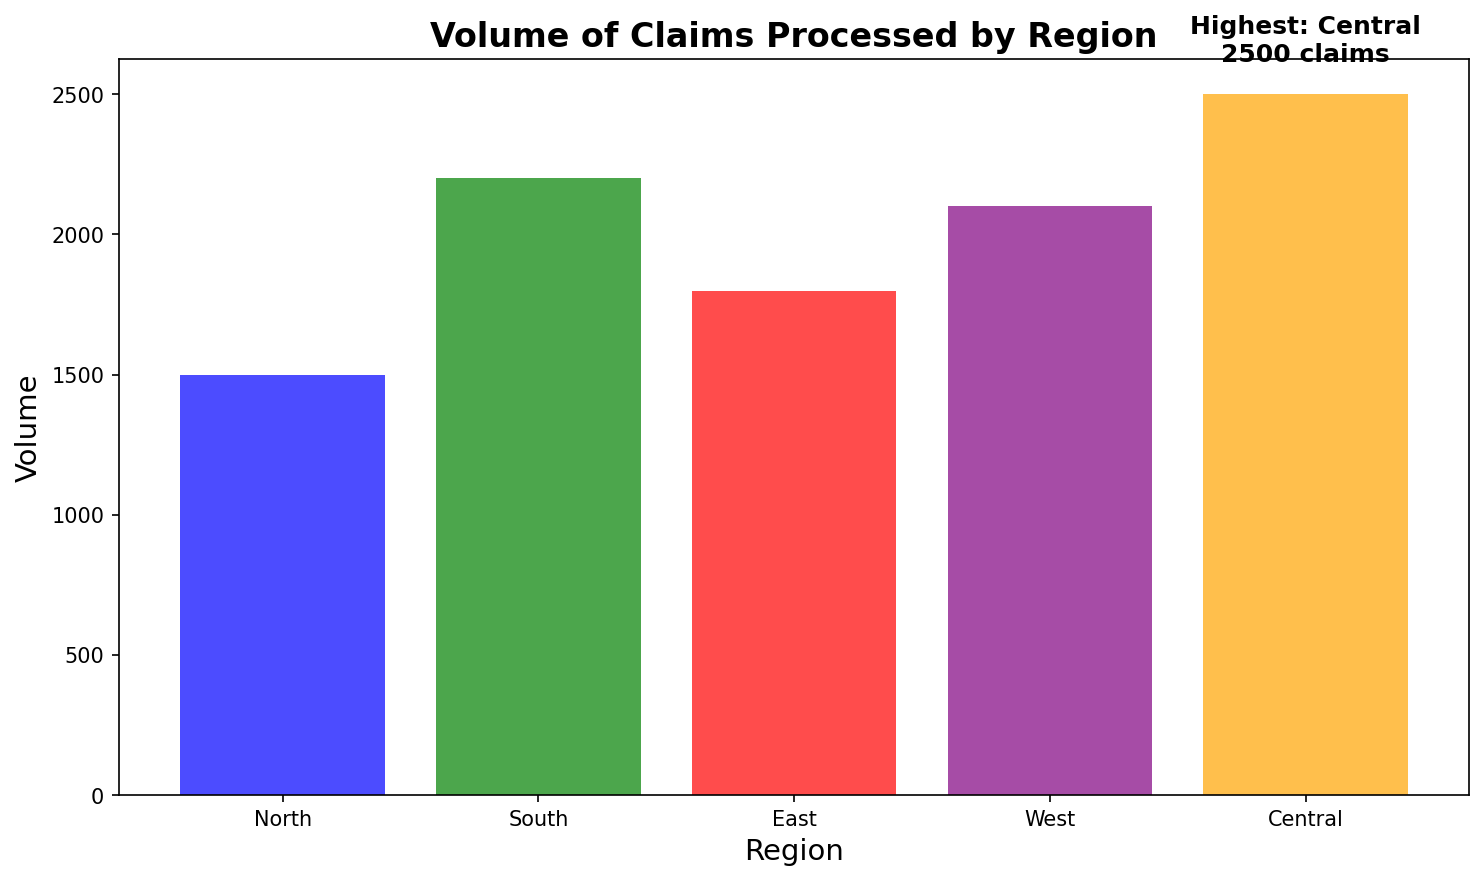Which region processes the highest volume of claims? To determine which region processes the highest volume of claims, look for the bar with the highest value on the y-axis. Additionally, the annotation at the top of this bar indicates the highest volume. The Central region has the highest volume, as annotated with "Highest: Central\n2500 claims".
Answer: Central What is the total volume of claims processed by the North and East regions combined? Look at the y-axis values for the North and East regions and add them together. North processes 1500 claims and East processes 1800 claims. Therefore, 1500 + 1800 = 3300.
Answer: 3300 Which region processes fewer claims, West or South? To compare the volumes of the West and South regions, look at the height of their respective bars on the y-axis. The bar for the West region reaches 2100 claims, while the bar for the South region is higher at 2200 claims. Hence, the West region processes fewer claims.
Answer: West How much larger is the volume of claims processed by the Central region compared to the North? To find how much larger Central's volume is compared to North's, subtract the North region's volume from the Central region's volume. The Central region processes 2500 claims, and the North region processes 1500 claims. So, 2500 - 1500 = 1000.
Answer: 1000 What is the average volume of claims processed across all regions? To calculate the average volume of claims processed across all regions, sum the volumes for all regions and then divide by the number of regions. The volumes are North (1500), South (2200), East (1800), West (2100), and Central (2500). The sum is 1500 + 2200 + 1800 + 2100 + 2500 = 10100. There are 5 regions, so, 10100 / 5 = 2020.
Answer: 2020 Which region's volume is closest to the average volume? First, calculate the average volume, which is 2020. Then, compare this value to each region's volume and find the one that is closest: North (1500), South (2200), East (1800), West (2100), and Central (2500). The differences are: North (520), South (180), East (220), West (80), and Central (480). The West region has the smallest difference from the average.
Answer: West What color is the bar representing the South region? To identify the color of the bar representing the South region, look at the visual attributes of the bars in the chart. The South region's bar is green in color.
Answer: Green How many more claims does the South region process compared to the East region? Subtract the volume of claims processed by the East region from the volume of claims processed by the South region. The South region processes 2200 claims, and the East region processes 1800 claims. So, 2200 - 1800 = 400.
Answer: 400 Which two regions have the closest volumes of claims processed? Compare the volumes of claims processed by each pair of regions and identify the pair with the smallest difference: North (1500), South (2200), East (1800), West (2100), and Central (2500). The pairs and differences are: North and South (700), North and East (300), North and West (600), North and Central (1000), South and East (400), South and West (100), South and Central (300), East and West (300), East and Central (700), West and Central (400). The closest are South and West, with a difference of 100.
Answer: South and West 